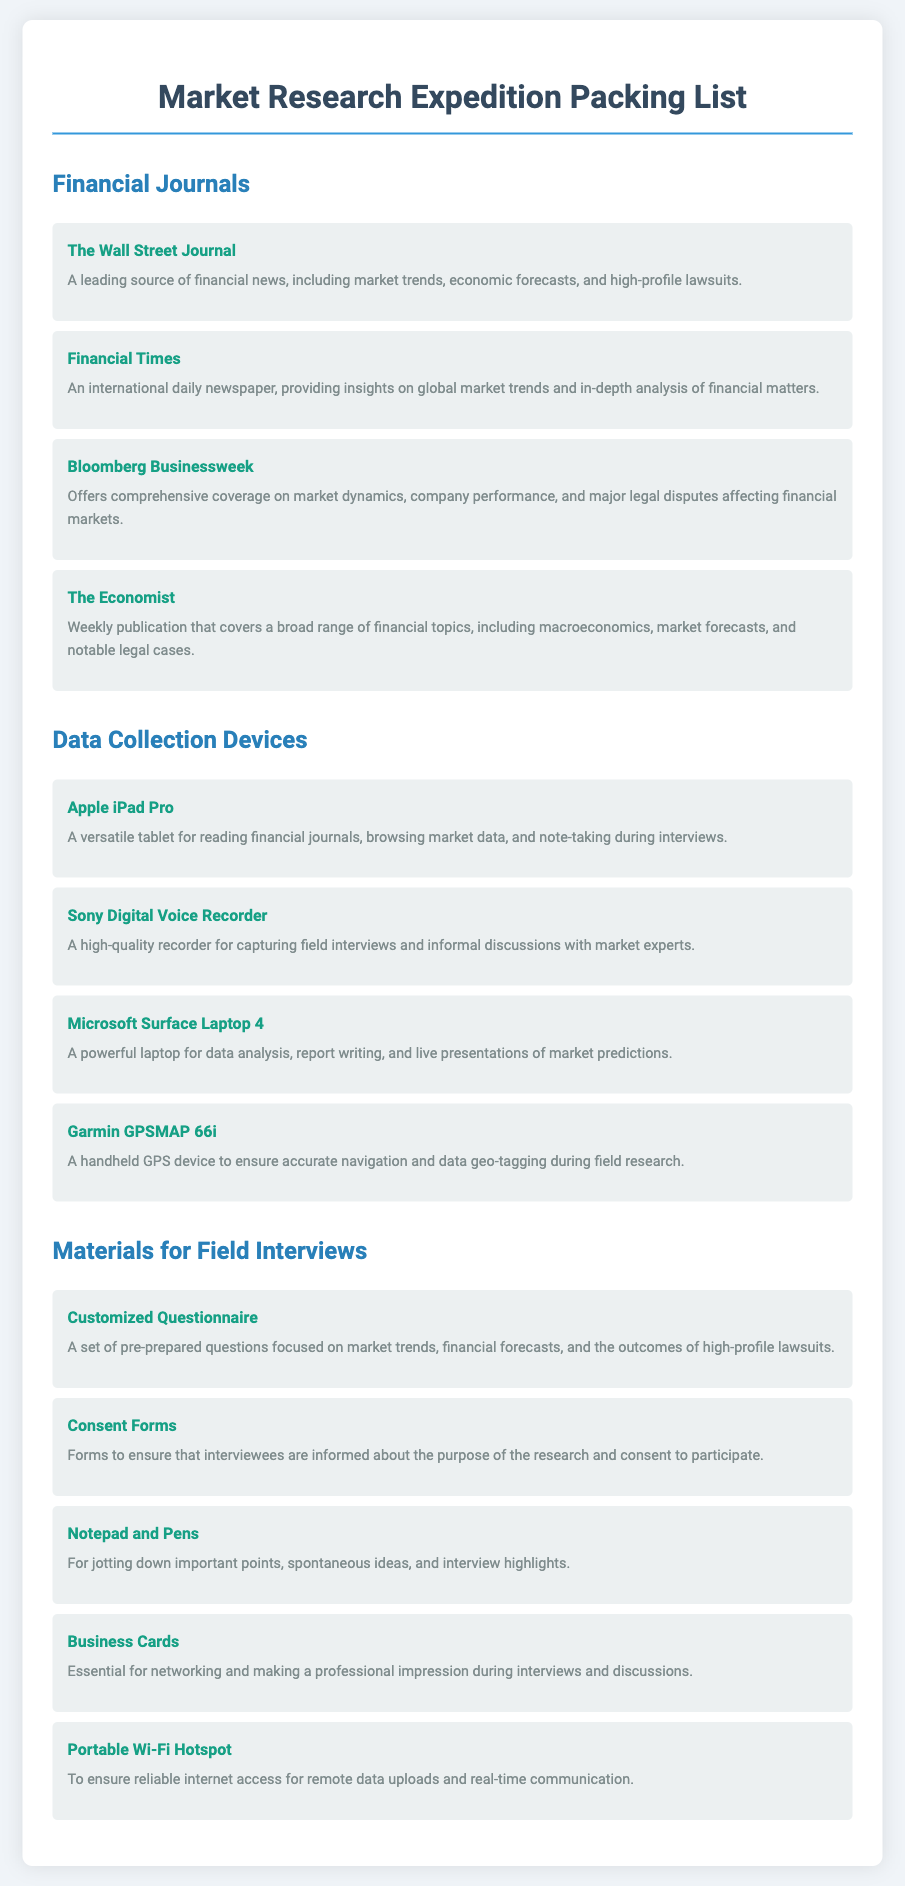what is a leading source of financial news? The document lists "The Wall Street Journal" as a leading source of financial news, including market trends and economic forecasts.
Answer: The Wall Street Journal what type of device is the Sony Digital Voice Recorder? The document categorizes it under "Data Collection Devices," highlighting its purpose of capturing field interviews.
Answer: Data Collection Device how many financial journals are listed in the packing list? The document includes a list of four financial journals under the section titled "Financial Journals."
Answer: Four what is the purpose of the Customized Questionnaire? The document states that the Customized Questionnaire is prepared for focused inquiries on market trends, financial forecasts, and lawsuits.
Answer: Focused inquiries which laptop model is mentioned for data analysis? The packing list specifies the "Microsoft Surface Laptop 4" as the model for data analysis and report writing.
Answer: Microsoft Surface Laptop 4 what essential item is mentioned for networking during interviews? In the materials for field interviews, "Business Cards" are highlighted as essential for making professional impressions.
Answer: Business Cards how is the Garmin GPSMAP 66i utilized during field research? The document mentions that the Garmin GPSMAP 66i is used to ensure accurate navigation and geo-tagging of data.
Answer: Accurate navigation what type of forms are included for interviewees? The document refers to "Consent Forms" that are vital for ensuring interviewee participation in the research.
Answer: Consent Forms 